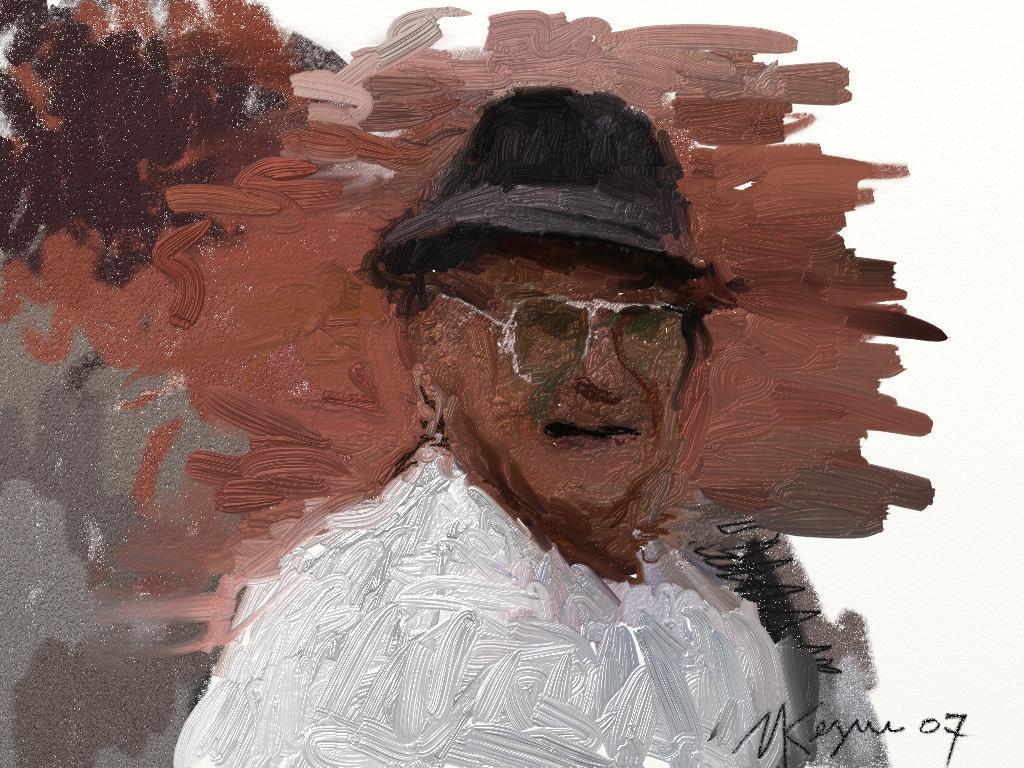Can you describe this image briefly? In this image I can see painting of a person. On the right bottom side I can see something is written. I can see color of this painting is brown, black, grey and white. 